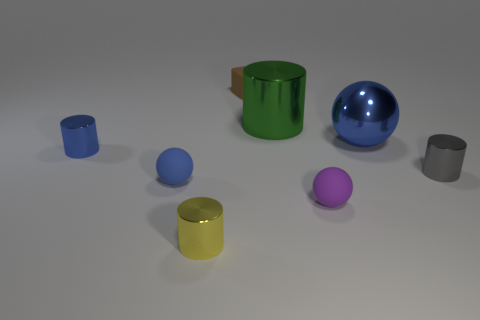Do the blue thing on the right side of the tiny brown cube and the brown thing have the same shape?
Your response must be concise. No. There is a gray thing that is the same material as the big ball; what is its size?
Your answer should be very brief. Small. How many things are metallic things that are to the right of the big green metal object or tiny matte things in front of the big green thing?
Make the answer very short. 4. Is the number of gray things in front of the gray shiny thing the same as the number of brown objects that are to the left of the tiny yellow cylinder?
Provide a succinct answer. Yes. The big shiny object that is to the left of the big metal ball is what color?
Give a very brief answer. Green. Do the block and the thing that is in front of the small purple object have the same color?
Your response must be concise. No. Are there fewer large gray metal balls than large blue metal objects?
Provide a succinct answer. Yes. Does the tiny shiny object on the right side of the yellow shiny object have the same color as the big metallic ball?
Your answer should be compact. No. What number of shiny balls have the same size as the green thing?
Provide a succinct answer. 1. Are there any tiny things that have the same color as the large metallic ball?
Ensure brevity in your answer.  Yes. 